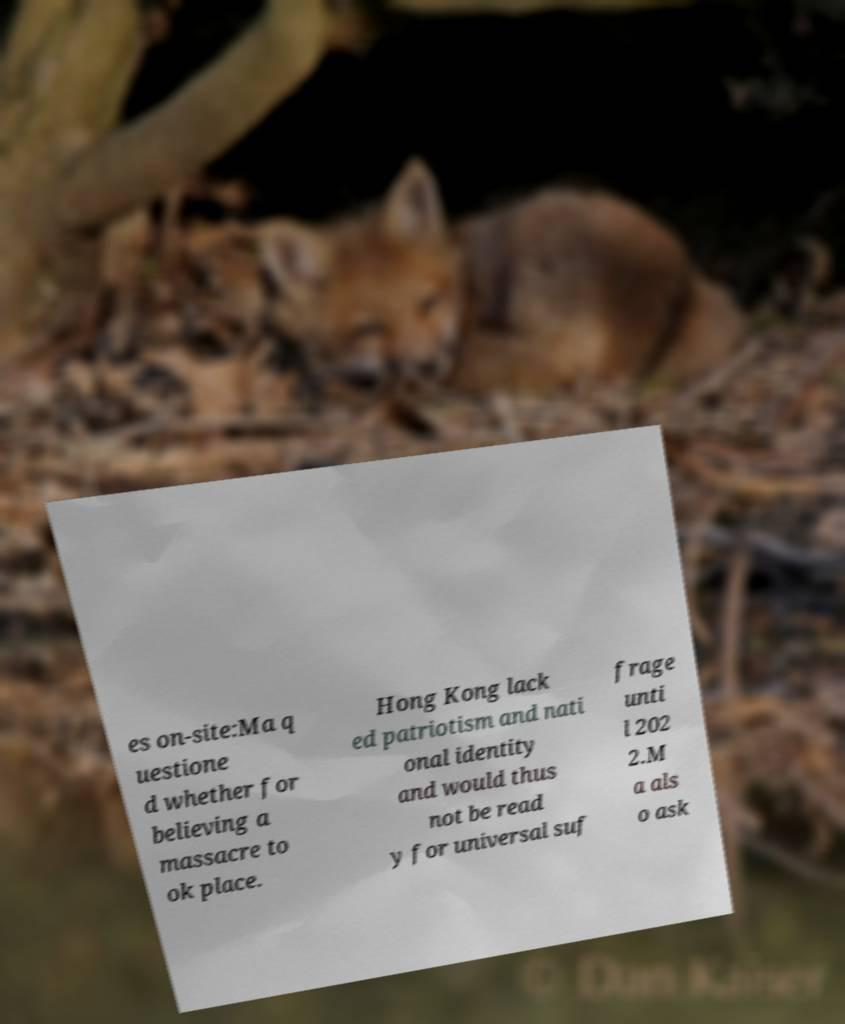I need the written content from this picture converted into text. Can you do that? es on-site:Ma q uestione d whether for believing a massacre to ok place. Hong Kong lack ed patriotism and nati onal identity and would thus not be read y for universal suf frage unti l 202 2.M a als o ask 